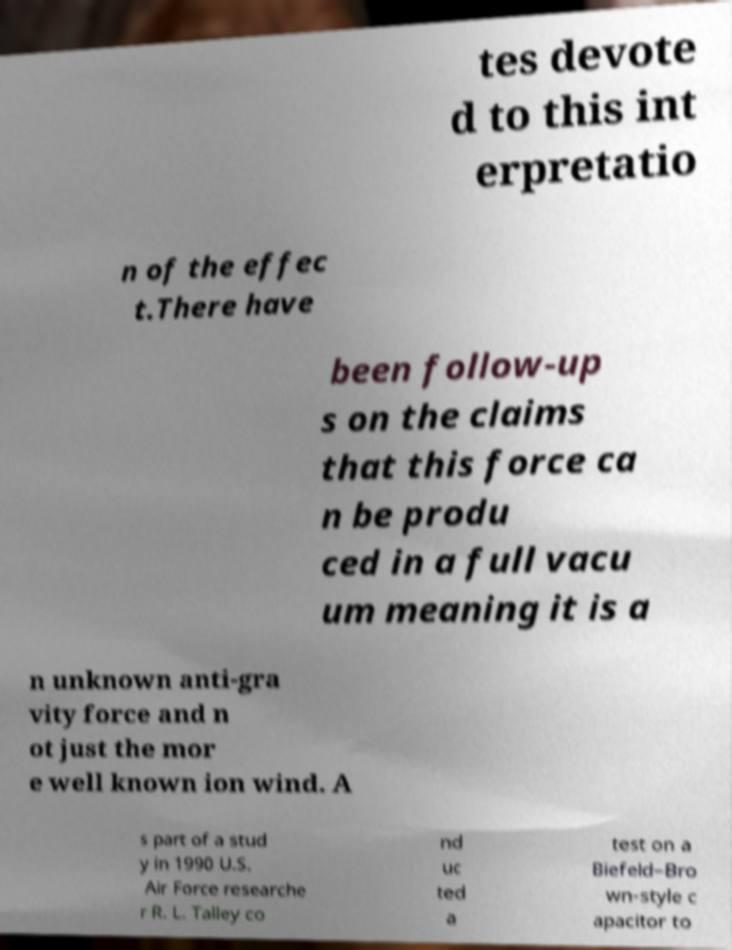For documentation purposes, I need the text within this image transcribed. Could you provide that? tes devote d to this int erpretatio n of the effec t.There have been follow-up s on the claims that this force ca n be produ ced in a full vacu um meaning it is a n unknown anti-gra vity force and n ot just the mor e well known ion wind. A s part of a stud y in 1990 U.S. Air Force researche r R. L. Talley co nd uc ted a test on a Biefeld–Bro wn-style c apacitor to 